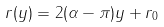Convert formula to latex. <formula><loc_0><loc_0><loc_500><loc_500>r ( y ) = 2 ( \alpha - \pi ) y + r _ { 0 }</formula> 